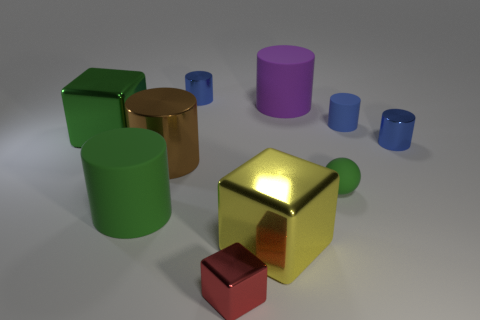How do the colors of the objects contribute to the overall aesthetics of the image? The colors of the objects – green, gold, purple, blue, and red – are varied and create a visually pleasing palette. These hues deliver contrast against the neutral background, accentuate the three-dimensional forms, and add vibrancy to the composition. 